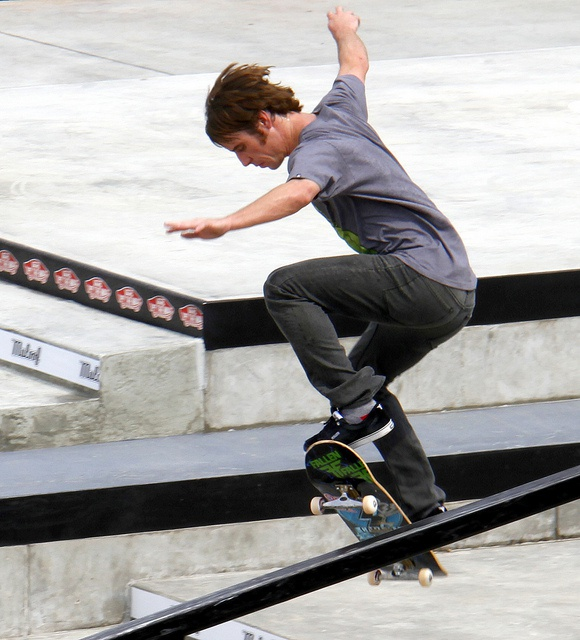Describe the objects in this image and their specific colors. I can see people in blue, black, darkgray, gray, and white tones and skateboard in blue, black, gray, darkgreen, and darkgray tones in this image. 